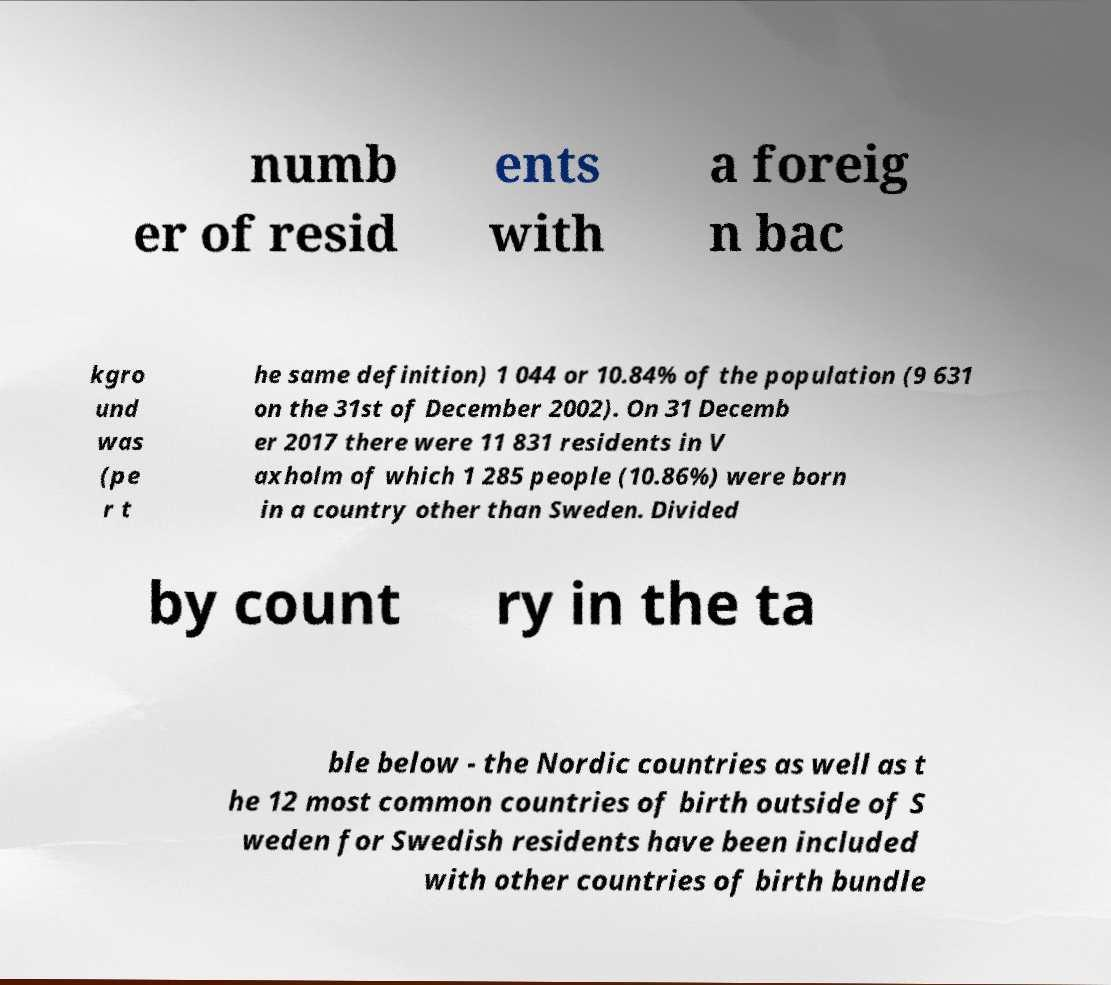Could you assist in decoding the text presented in this image and type it out clearly? numb er of resid ents with a foreig n bac kgro und was (pe r t he same definition) 1 044 or 10.84% of the population (9 631 on the 31st of December 2002). On 31 Decemb er 2017 there were 11 831 residents in V axholm of which 1 285 people (10.86%) were born in a country other than Sweden. Divided by count ry in the ta ble below - the Nordic countries as well as t he 12 most common countries of birth outside of S weden for Swedish residents have been included with other countries of birth bundle 